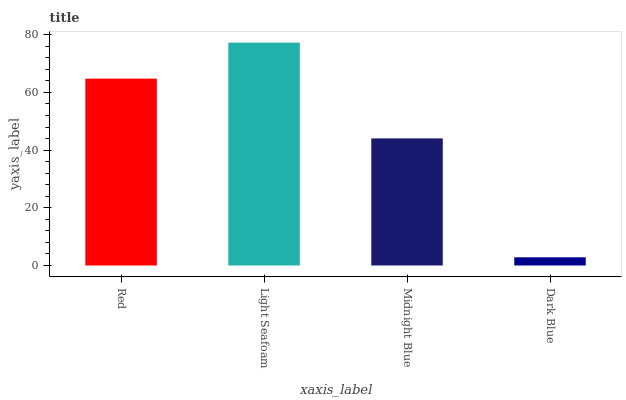Is Dark Blue the minimum?
Answer yes or no. Yes. Is Light Seafoam the maximum?
Answer yes or no. Yes. Is Midnight Blue the minimum?
Answer yes or no. No. Is Midnight Blue the maximum?
Answer yes or no. No. Is Light Seafoam greater than Midnight Blue?
Answer yes or no. Yes. Is Midnight Blue less than Light Seafoam?
Answer yes or no. Yes. Is Midnight Blue greater than Light Seafoam?
Answer yes or no. No. Is Light Seafoam less than Midnight Blue?
Answer yes or no. No. Is Red the high median?
Answer yes or no. Yes. Is Midnight Blue the low median?
Answer yes or no. Yes. Is Midnight Blue the high median?
Answer yes or no. No. Is Dark Blue the low median?
Answer yes or no. No. 